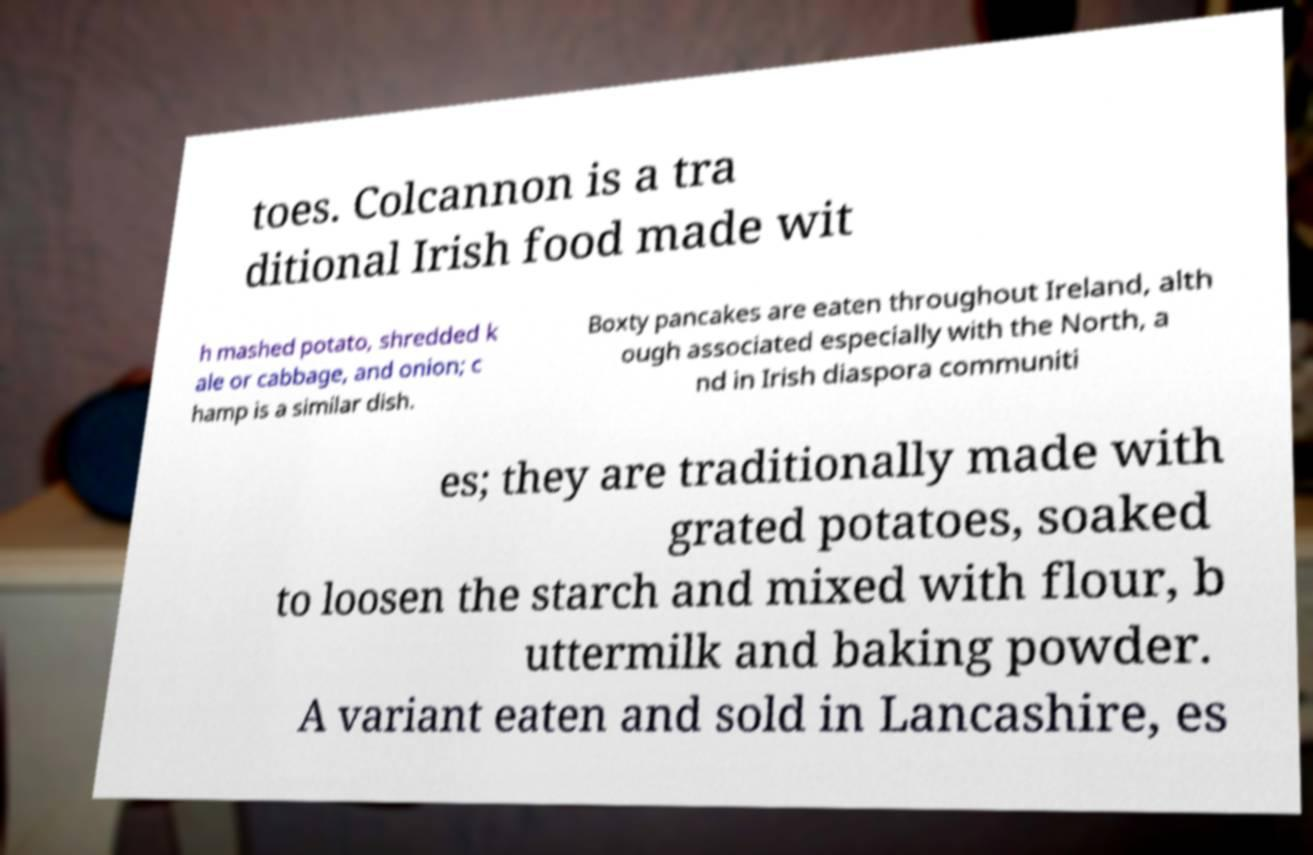For documentation purposes, I need the text within this image transcribed. Could you provide that? toes. Colcannon is a tra ditional Irish food made wit h mashed potato, shredded k ale or cabbage, and onion; c hamp is a similar dish. Boxty pancakes are eaten throughout Ireland, alth ough associated especially with the North, a nd in Irish diaspora communiti es; they are traditionally made with grated potatoes, soaked to loosen the starch and mixed with flour, b uttermilk and baking powder. A variant eaten and sold in Lancashire, es 